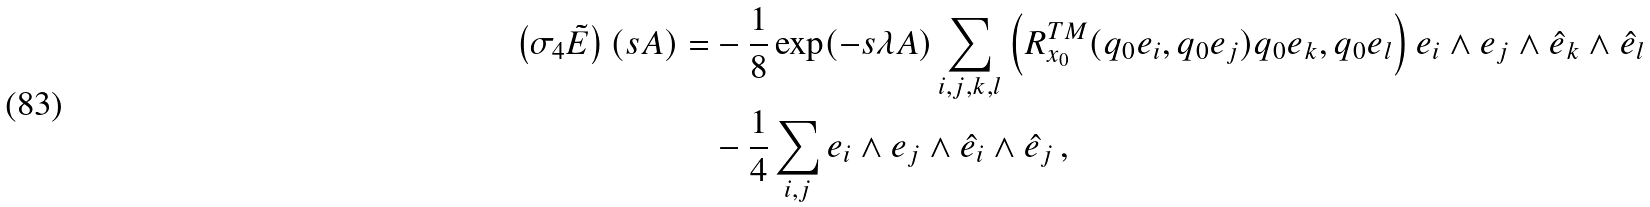<formula> <loc_0><loc_0><loc_500><loc_500>\left ( \sigma _ { 4 } \tilde { E } \right ) ( s A ) = & - \frac { 1 } { 8 } \exp ( - s \lambda A ) \sum _ { i , j , k , l } \left ( R _ { x _ { 0 } } ^ { T M } ( q _ { 0 } e _ { i } , q _ { 0 } e _ { j } ) q _ { 0 } e _ { k } , q _ { 0 } e _ { l } \right ) e _ { i } \wedge e _ { j } \wedge \hat { e } _ { k } \wedge \hat { e } _ { l } \\ & - \frac { 1 } { 4 } \sum _ { i , j } e _ { i } \wedge e _ { j } \wedge \hat { e } _ { i } \wedge \hat { e } _ { j } \, ,</formula> 